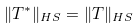<formula> <loc_0><loc_0><loc_500><loc_500>\| T ^ { * } \| _ { H S } = \| T \| _ { H S }</formula> 